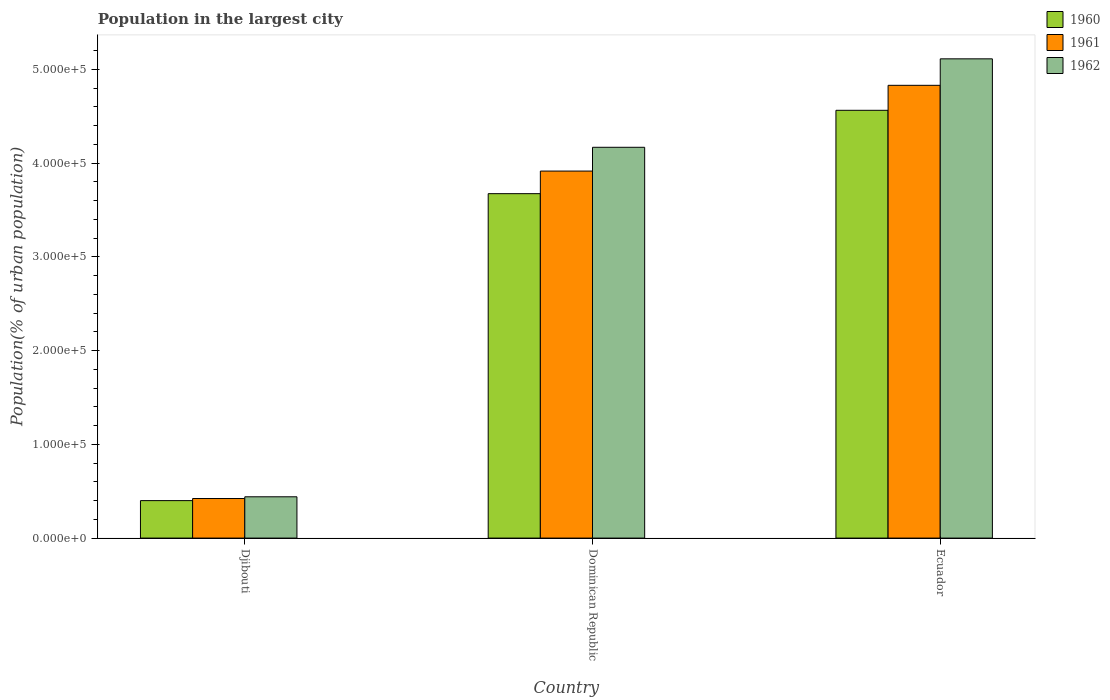Are the number of bars on each tick of the X-axis equal?
Provide a succinct answer. Yes. How many bars are there on the 2nd tick from the left?
Offer a very short reply. 3. How many bars are there on the 1st tick from the right?
Offer a very short reply. 3. What is the label of the 3rd group of bars from the left?
Offer a terse response. Ecuador. What is the population in the largest city in 1960 in Dominican Republic?
Provide a short and direct response. 3.67e+05. Across all countries, what is the maximum population in the largest city in 1960?
Provide a short and direct response. 4.56e+05. Across all countries, what is the minimum population in the largest city in 1962?
Provide a short and direct response. 4.40e+04. In which country was the population in the largest city in 1962 maximum?
Make the answer very short. Ecuador. In which country was the population in the largest city in 1961 minimum?
Make the answer very short. Djibouti. What is the total population in the largest city in 1960 in the graph?
Ensure brevity in your answer.  8.64e+05. What is the difference between the population in the largest city in 1961 in Dominican Republic and that in Ecuador?
Your answer should be very brief. -9.14e+04. What is the difference between the population in the largest city in 1961 in Ecuador and the population in the largest city in 1960 in Dominican Republic?
Your response must be concise. 1.16e+05. What is the average population in the largest city in 1960 per country?
Ensure brevity in your answer.  2.88e+05. What is the difference between the population in the largest city of/in 1962 and population in the largest city of/in 1960 in Djibouti?
Give a very brief answer. 4084. What is the ratio of the population in the largest city in 1960 in Djibouti to that in Ecuador?
Provide a short and direct response. 0.09. Is the population in the largest city in 1960 in Djibouti less than that in Ecuador?
Your response must be concise. Yes. Is the difference between the population in the largest city in 1962 in Djibouti and Ecuador greater than the difference between the population in the largest city in 1960 in Djibouti and Ecuador?
Your answer should be compact. No. What is the difference between the highest and the second highest population in the largest city in 1961?
Keep it short and to the point. -9.14e+04. What is the difference between the highest and the lowest population in the largest city in 1961?
Make the answer very short. 4.41e+05. What does the 2nd bar from the left in Ecuador represents?
Your answer should be compact. 1961. What does the 1st bar from the right in Ecuador represents?
Offer a very short reply. 1962. Is it the case that in every country, the sum of the population in the largest city in 1960 and population in the largest city in 1961 is greater than the population in the largest city in 1962?
Offer a terse response. Yes. Are all the bars in the graph horizontal?
Provide a short and direct response. No. How many countries are there in the graph?
Make the answer very short. 3. What is the difference between two consecutive major ticks on the Y-axis?
Ensure brevity in your answer.  1.00e+05. Are the values on the major ticks of Y-axis written in scientific E-notation?
Your answer should be compact. Yes. Does the graph contain grids?
Give a very brief answer. No. Where does the legend appear in the graph?
Offer a terse response. Top right. How are the legend labels stacked?
Your answer should be compact. Vertical. What is the title of the graph?
Keep it short and to the point. Population in the largest city. Does "1978" appear as one of the legend labels in the graph?
Provide a short and direct response. No. What is the label or title of the X-axis?
Offer a very short reply. Country. What is the label or title of the Y-axis?
Offer a terse response. Population(% of urban population). What is the Population(% of urban population) of 1960 in Djibouti?
Offer a terse response. 4.00e+04. What is the Population(% of urban population) of 1961 in Djibouti?
Give a very brief answer. 4.22e+04. What is the Population(% of urban population) of 1962 in Djibouti?
Your answer should be very brief. 4.40e+04. What is the Population(% of urban population) of 1960 in Dominican Republic?
Your answer should be very brief. 3.67e+05. What is the Population(% of urban population) of 1961 in Dominican Republic?
Your response must be concise. 3.91e+05. What is the Population(% of urban population) of 1962 in Dominican Republic?
Offer a very short reply. 4.17e+05. What is the Population(% of urban population) of 1960 in Ecuador?
Ensure brevity in your answer.  4.56e+05. What is the Population(% of urban population) of 1961 in Ecuador?
Make the answer very short. 4.83e+05. What is the Population(% of urban population) of 1962 in Ecuador?
Your response must be concise. 5.11e+05. Across all countries, what is the maximum Population(% of urban population) in 1960?
Your response must be concise. 4.56e+05. Across all countries, what is the maximum Population(% of urban population) of 1961?
Your response must be concise. 4.83e+05. Across all countries, what is the maximum Population(% of urban population) in 1962?
Your response must be concise. 5.11e+05. Across all countries, what is the minimum Population(% of urban population) in 1960?
Keep it short and to the point. 4.00e+04. Across all countries, what is the minimum Population(% of urban population) in 1961?
Provide a succinct answer. 4.22e+04. Across all countries, what is the minimum Population(% of urban population) in 1962?
Your answer should be compact. 4.40e+04. What is the total Population(% of urban population) of 1960 in the graph?
Your response must be concise. 8.64e+05. What is the total Population(% of urban population) in 1961 in the graph?
Your answer should be very brief. 9.17e+05. What is the total Population(% of urban population) in 1962 in the graph?
Provide a short and direct response. 9.72e+05. What is the difference between the Population(% of urban population) of 1960 in Djibouti and that in Dominican Republic?
Ensure brevity in your answer.  -3.27e+05. What is the difference between the Population(% of urban population) in 1961 in Djibouti and that in Dominican Republic?
Provide a succinct answer. -3.49e+05. What is the difference between the Population(% of urban population) of 1962 in Djibouti and that in Dominican Republic?
Provide a succinct answer. -3.73e+05. What is the difference between the Population(% of urban population) of 1960 in Djibouti and that in Ecuador?
Provide a short and direct response. -4.16e+05. What is the difference between the Population(% of urban population) of 1961 in Djibouti and that in Ecuador?
Offer a terse response. -4.41e+05. What is the difference between the Population(% of urban population) in 1962 in Djibouti and that in Ecuador?
Offer a terse response. -4.67e+05. What is the difference between the Population(% of urban population) in 1960 in Dominican Republic and that in Ecuador?
Provide a short and direct response. -8.89e+04. What is the difference between the Population(% of urban population) of 1961 in Dominican Republic and that in Ecuador?
Provide a succinct answer. -9.14e+04. What is the difference between the Population(% of urban population) in 1962 in Dominican Republic and that in Ecuador?
Provide a succinct answer. -9.43e+04. What is the difference between the Population(% of urban population) in 1960 in Djibouti and the Population(% of urban population) in 1961 in Dominican Republic?
Provide a short and direct response. -3.51e+05. What is the difference between the Population(% of urban population) of 1960 in Djibouti and the Population(% of urban population) of 1962 in Dominican Republic?
Offer a very short reply. -3.77e+05. What is the difference between the Population(% of urban population) of 1961 in Djibouti and the Population(% of urban population) of 1962 in Dominican Republic?
Ensure brevity in your answer.  -3.75e+05. What is the difference between the Population(% of urban population) of 1960 in Djibouti and the Population(% of urban population) of 1961 in Ecuador?
Keep it short and to the point. -4.43e+05. What is the difference between the Population(% of urban population) of 1960 in Djibouti and the Population(% of urban population) of 1962 in Ecuador?
Your answer should be very brief. -4.71e+05. What is the difference between the Population(% of urban population) of 1961 in Djibouti and the Population(% of urban population) of 1962 in Ecuador?
Your response must be concise. -4.69e+05. What is the difference between the Population(% of urban population) of 1960 in Dominican Republic and the Population(% of urban population) of 1961 in Ecuador?
Provide a succinct answer. -1.16e+05. What is the difference between the Population(% of urban population) of 1960 in Dominican Republic and the Population(% of urban population) of 1962 in Ecuador?
Make the answer very short. -1.44e+05. What is the difference between the Population(% of urban population) of 1961 in Dominican Republic and the Population(% of urban population) of 1962 in Ecuador?
Your answer should be very brief. -1.20e+05. What is the average Population(% of urban population) of 1960 per country?
Ensure brevity in your answer.  2.88e+05. What is the average Population(% of urban population) of 1961 per country?
Offer a terse response. 3.06e+05. What is the average Population(% of urban population) of 1962 per country?
Keep it short and to the point. 3.24e+05. What is the difference between the Population(% of urban population) of 1960 and Population(% of urban population) of 1961 in Djibouti?
Offer a very short reply. -2241. What is the difference between the Population(% of urban population) in 1960 and Population(% of urban population) in 1962 in Djibouti?
Provide a succinct answer. -4084. What is the difference between the Population(% of urban population) in 1961 and Population(% of urban population) in 1962 in Djibouti?
Offer a very short reply. -1843. What is the difference between the Population(% of urban population) of 1960 and Population(% of urban population) of 1961 in Dominican Republic?
Provide a short and direct response. -2.41e+04. What is the difference between the Population(% of urban population) in 1960 and Population(% of urban population) in 1962 in Dominican Republic?
Provide a short and direct response. -4.95e+04. What is the difference between the Population(% of urban population) in 1961 and Population(% of urban population) in 1962 in Dominican Republic?
Make the answer very short. -2.54e+04. What is the difference between the Population(% of urban population) of 1960 and Population(% of urban population) of 1961 in Ecuador?
Your response must be concise. -2.66e+04. What is the difference between the Population(% of urban population) in 1960 and Population(% of urban population) in 1962 in Ecuador?
Provide a short and direct response. -5.49e+04. What is the difference between the Population(% of urban population) in 1961 and Population(% of urban population) in 1962 in Ecuador?
Keep it short and to the point. -2.82e+04. What is the ratio of the Population(% of urban population) of 1960 in Djibouti to that in Dominican Republic?
Offer a terse response. 0.11. What is the ratio of the Population(% of urban population) of 1961 in Djibouti to that in Dominican Republic?
Give a very brief answer. 0.11. What is the ratio of the Population(% of urban population) in 1962 in Djibouti to that in Dominican Republic?
Ensure brevity in your answer.  0.11. What is the ratio of the Population(% of urban population) in 1960 in Djibouti to that in Ecuador?
Your answer should be very brief. 0.09. What is the ratio of the Population(% of urban population) in 1961 in Djibouti to that in Ecuador?
Keep it short and to the point. 0.09. What is the ratio of the Population(% of urban population) of 1962 in Djibouti to that in Ecuador?
Make the answer very short. 0.09. What is the ratio of the Population(% of urban population) of 1960 in Dominican Republic to that in Ecuador?
Ensure brevity in your answer.  0.81. What is the ratio of the Population(% of urban population) in 1961 in Dominican Republic to that in Ecuador?
Keep it short and to the point. 0.81. What is the ratio of the Population(% of urban population) of 1962 in Dominican Republic to that in Ecuador?
Ensure brevity in your answer.  0.82. What is the difference between the highest and the second highest Population(% of urban population) of 1960?
Ensure brevity in your answer.  8.89e+04. What is the difference between the highest and the second highest Population(% of urban population) in 1961?
Make the answer very short. 9.14e+04. What is the difference between the highest and the second highest Population(% of urban population) in 1962?
Your answer should be compact. 9.43e+04. What is the difference between the highest and the lowest Population(% of urban population) in 1960?
Your response must be concise. 4.16e+05. What is the difference between the highest and the lowest Population(% of urban population) of 1961?
Ensure brevity in your answer.  4.41e+05. What is the difference between the highest and the lowest Population(% of urban population) in 1962?
Ensure brevity in your answer.  4.67e+05. 